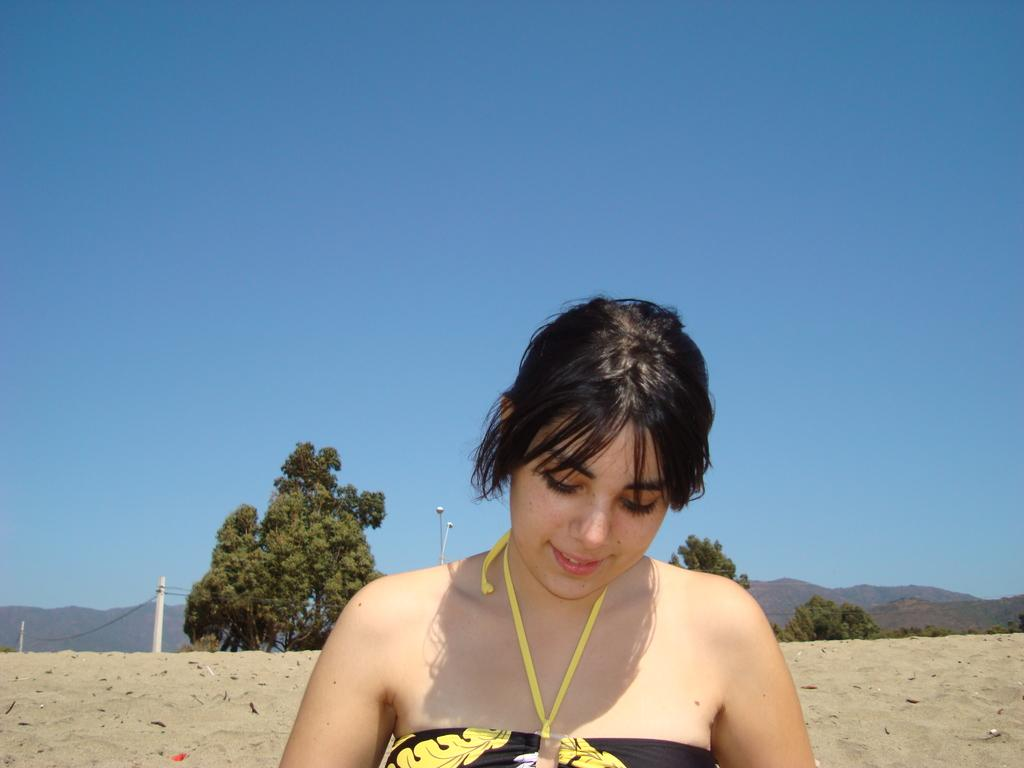Who is the main subject in the foreground of the picture? There is a woman in the foreground of the picture. What is the woman's expression in the picture? The woman is smiling. What type of natural environment can be seen in the background of the picture? There is sand, trees, mountains, and poles visible in the background of the picture. What part of the natural environment is not visible in the picture? The sky is visible in the background of the picture, so it is not missing. What type of steam can be seen coming from the woman's ears in the picture? There is no steam coming from the woman's ears in the picture. What day of the week is depicted in the image? The day of the week is not mentioned or depicted in the image. 